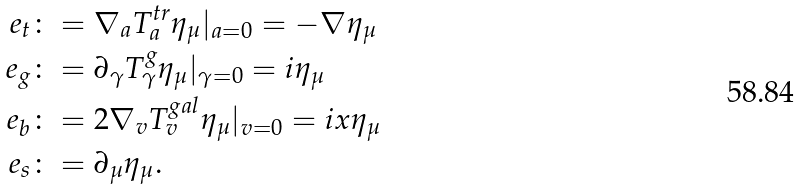Convert formula to latex. <formula><loc_0><loc_0><loc_500><loc_500>e _ { t } & \colon = \nabla _ { a } T _ { a } ^ { t r } \eta _ { \mu } | _ { a = 0 } = - \nabla \eta _ { \mu } \\ e _ { g } & \colon = \partial _ { \gamma } T _ { \gamma } ^ { g } \eta _ { \mu } | _ { \gamma = 0 } = i \eta _ { \mu } \\ e _ { b } & \colon = 2 \nabla _ { v } T _ { v } ^ { g a l } \eta _ { \mu } | _ { v = 0 } = i x \eta _ { \mu } \\ e _ { s } & \colon = \partial _ { \mu } \eta _ { \mu } .</formula> 